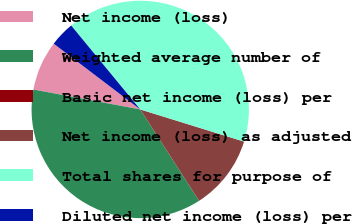<chart> <loc_0><loc_0><loc_500><loc_500><pie_chart><fcel>Net income (loss)<fcel>Weighted average number of<fcel>Basic net income (loss) per<fcel>Net income (loss) as adjusted<fcel>Total shares for purpose of<fcel>Diluted net income (loss) per<nl><fcel>7.41%<fcel>37.04%<fcel>0.0%<fcel>11.11%<fcel>40.74%<fcel>3.7%<nl></chart> 